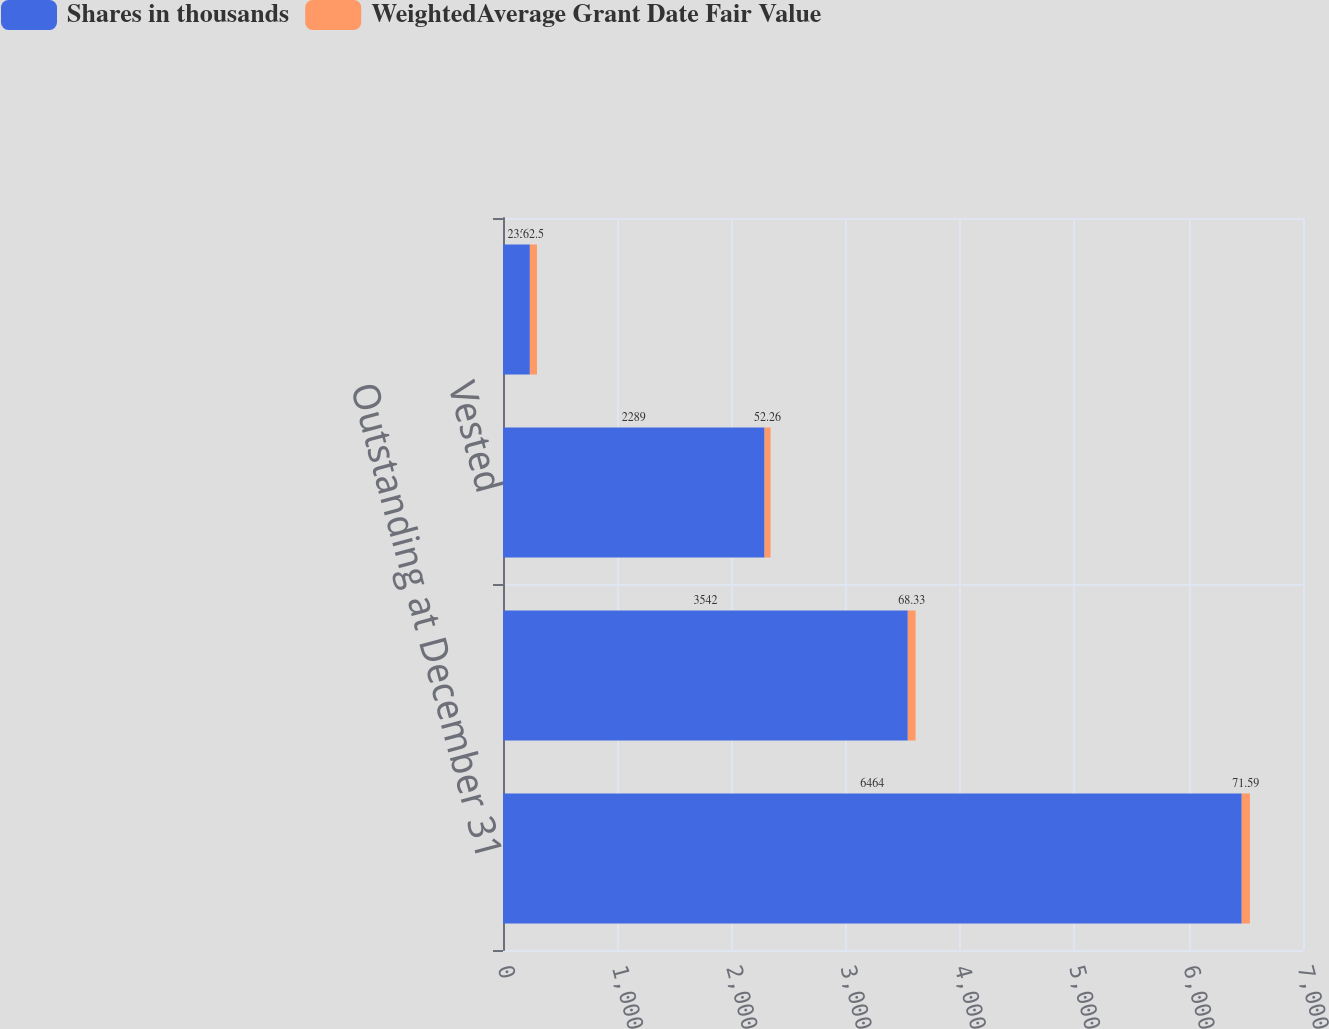<chart> <loc_0><loc_0><loc_500><loc_500><stacked_bar_chart><ecel><fcel>Outstanding at December 31<fcel>Granted<fcel>Vested<fcel>Forfeited<nl><fcel>Shares in thousands<fcel>6464<fcel>3542<fcel>2289<fcel>235<nl><fcel>WeightedAverage Grant Date Fair Value<fcel>71.59<fcel>68.33<fcel>52.26<fcel>62.5<nl></chart> 